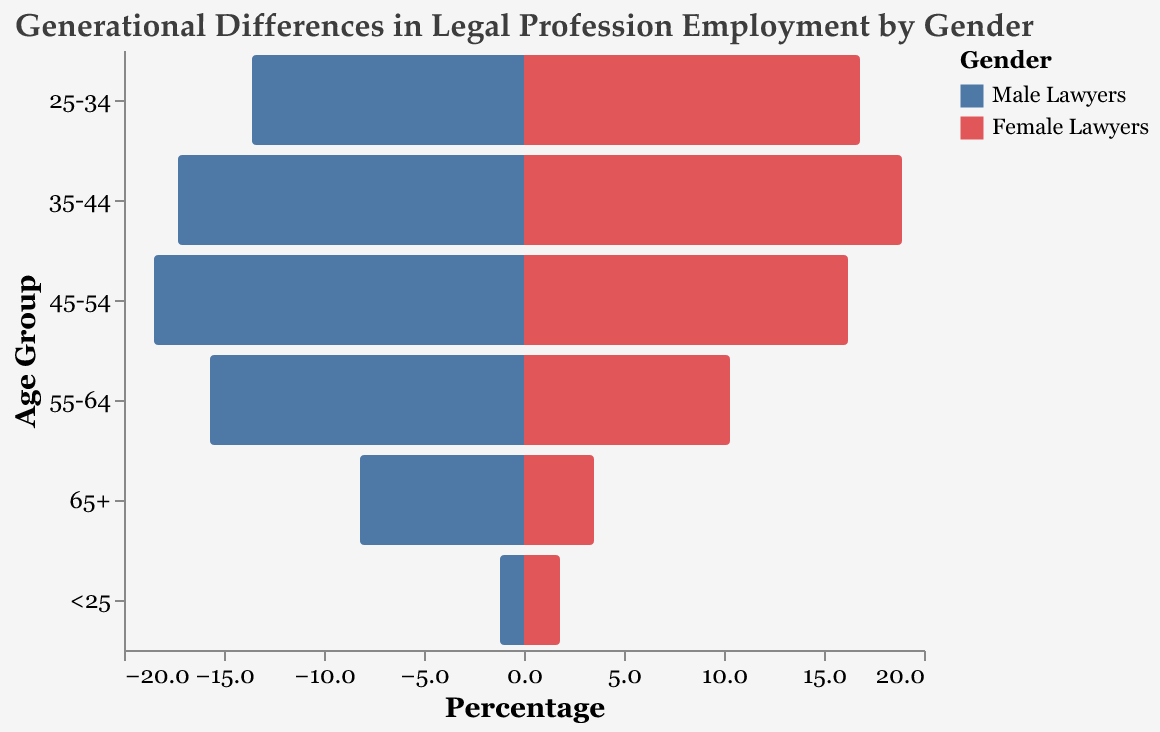What is the title of the figure? The title of the figure is typically displayed at the top of the chart, and it describes what the figure is about.
Answer: Generational Differences in Legal Profession Employment by Gender What age group has the highest percentage of male lawyers? Looking at the bars associated with male lawyers, we find the tallest bar, which indicates the highest percentage.
Answer: 45-54 Which gender has a higher percentage in the 35-44 age group? Compare the length of the bars for both males and females within the 35-44 age group.
Answer: Female Lawyers What is the percentage difference between male and female lawyers in the 25-34 age group? Subtract the percentage of male lawyers from the percentage of female lawyers in the 25-34 age group. Calculation: 16.8 (Female) - 13.6 (Male) = 3.2
Answer: 3.2 Which age group has the smallest percentage of total lawyers? By examining the lengths of the bars across all age groups, identify the group with the smallest combined percentage for both genders.
Answer: <25 How does the percentage of female lawyers in the 45-54 age group compare to that in the 35-44 age group? Compare the heights of the bars representing female lawyers in both age groups.
Answer: 45-54 has a lower percentage than 35-44 What trends can you observe about gender distribution in the legal profession across different age groups? Analyze the pattern in gender representation by looking at the bars for each age group. Generally, see if one gender increases or decreases while the other does the same.
Answer: In older age groups, male lawyers dominate, while in younger age groups, female lawyers tend to be more prevalent or closer in proportion What age group has the most balanced gender distribution of lawyers? Check for the age group where the lengths of the male and female bars are the closest to each other.
Answer: 45-54 How has female representation in the legal profession changed across generations? Observe the trend in the heights of the bars for female lawyers from the oldest to the youngest age groups.
Answer: Female representation increases in younger age groups Calculate the total percentage of lawyers in the 55-64 age group. Add the percentages of male and female lawyers within this age group. Calculation: 15.7 (Male) + 10.3 (Female) = 26
Answer: 26 